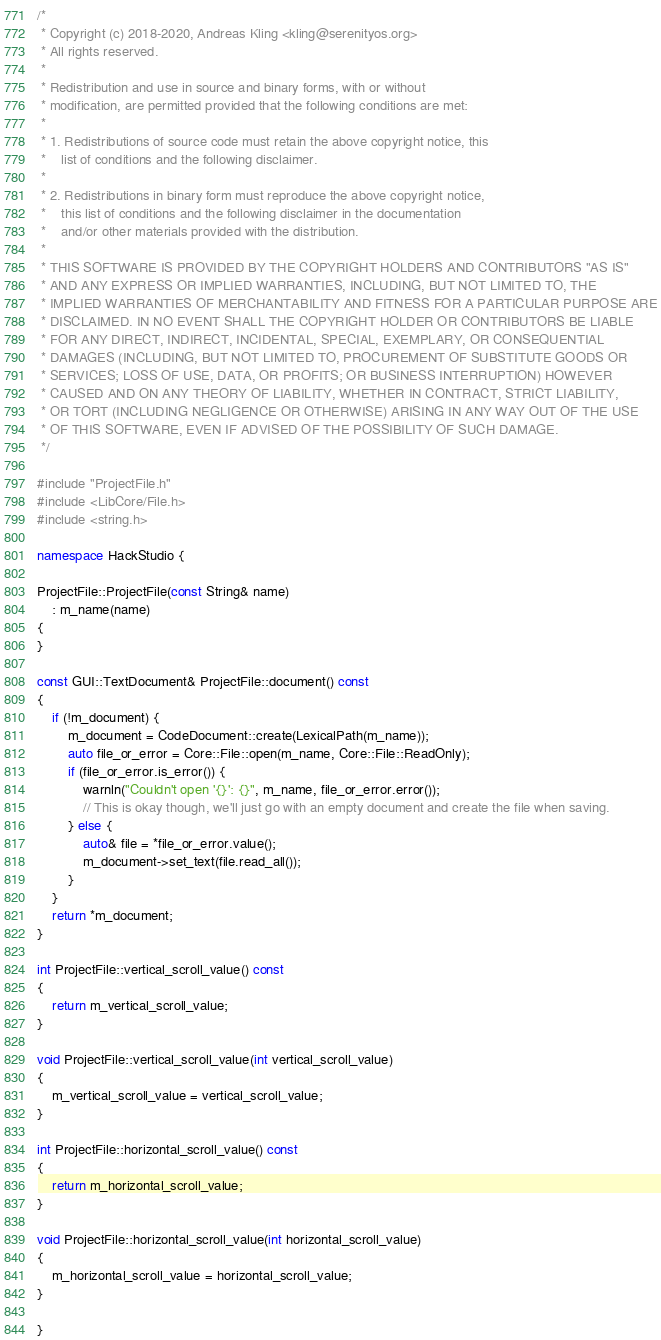Convert code to text. <code><loc_0><loc_0><loc_500><loc_500><_C++_>/*
 * Copyright (c) 2018-2020, Andreas Kling <kling@serenityos.org>
 * All rights reserved.
 *
 * Redistribution and use in source and binary forms, with or without
 * modification, are permitted provided that the following conditions are met:
 *
 * 1. Redistributions of source code must retain the above copyright notice, this
 *    list of conditions and the following disclaimer.
 *
 * 2. Redistributions in binary form must reproduce the above copyright notice,
 *    this list of conditions and the following disclaimer in the documentation
 *    and/or other materials provided with the distribution.
 *
 * THIS SOFTWARE IS PROVIDED BY THE COPYRIGHT HOLDERS AND CONTRIBUTORS "AS IS"
 * AND ANY EXPRESS OR IMPLIED WARRANTIES, INCLUDING, BUT NOT LIMITED TO, THE
 * IMPLIED WARRANTIES OF MERCHANTABILITY AND FITNESS FOR A PARTICULAR PURPOSE ARE
 * DISCLAIMED. IN NO EVENT SHALL THE COPYRIGHT HOLDER OR CONTRIBUTORS BE LIABLE
 * FOR ANY DIRECT, INDIRECT, INCIDENTAL, SPECIAL, EXEMPLARY, OR CONSEQUENTIAL
 * DAMAGES (INCLUDING, BUT NOT LIMITED TO, PROCUREMENT OF SUBSTITUTE GOODS OR
 * SERVICES; LOSS OF USE, DATA, OR PROFITS; OR BUSINESS INTERRUPTION) HOWEVER
 * CAUSED AND ON ANY THEORY OF LIABILITY, WHETHER IN CONTRACT, STRICT LIABILITY,
 * OR TORT (INCLUDING NEGLIGENCE OR OTHERWISE) ARISING IN ANY WAY OUT OF THE USE
 * OF THIS SOFTWARE, EVEN IF ADVISED OF THE POSSIBILITY OF SUCH DAMAGE.
 */

#include "ProjectFile.h"
#include <LibCore/File.h>
#include <string.h>

namespace HackStudio {

ProjectFile::ProjectFile(const String& name)
    : m_name(name)
{
}

const GUI::TextDocument& ProjectFile::document() const
{
    if (!m_document) {
        m_document = CodeDocument::create(LexicalPath(m_name));
        auto file_or_error = Core::File::open(m_name, Core::File::ReadOnly);
        if (file_or_error.is_error()) {
            warnln("Couldn't open '{}': {}", m_name, file_or_error.error());
            // This is okay though, we'll just go with an empty document and create the file when saving.
        } else {
            auto& file = *file_or_error.value();
            m_document->set_text(file.read_all());
        }
    }
    return *m_document;
}

int ProjectFile::vertical_scroll_value() const
{
    return m_vertical_scroll_value;
}

void ProjectFile::vertical_scroll_value(int vertical_scroll_value)
{
    m_vertical_scroll_value = vertical_scroll_value;
}

int ProjectFile::horizontal_scroll_value() const
{
    return m_horizontal_scroll_value;
}

void ProjectFile::horizontal_scroll_value(int horizontal_scroll_value)
{
    m_horizontal_scroll_value = horizontal_scroll_value;
}

}
</code> 